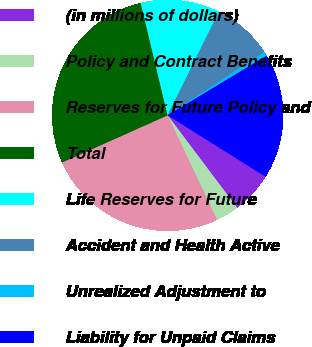<chart> <loc_0><loc_0><loc_500><loc_500><pie_chart><fcel>(in millions of dollars)<fcel>Policy and Contract Benefits<fcel>Reserves for Future Policy and<fcel>Total<fcel>Life Reserves for Future<fcel>Accident and Health Active<fcel>Unrealized Adjustment to<fcel>Liability for Unpaid Claims<nl><fcel>5.83%<fcel>3.22%<fcel>25.34%<fcel>27.95%<fcel>11.06%<fcel>8.45%<fcel>0.61%<fcel>17.53%<nl></chart> 